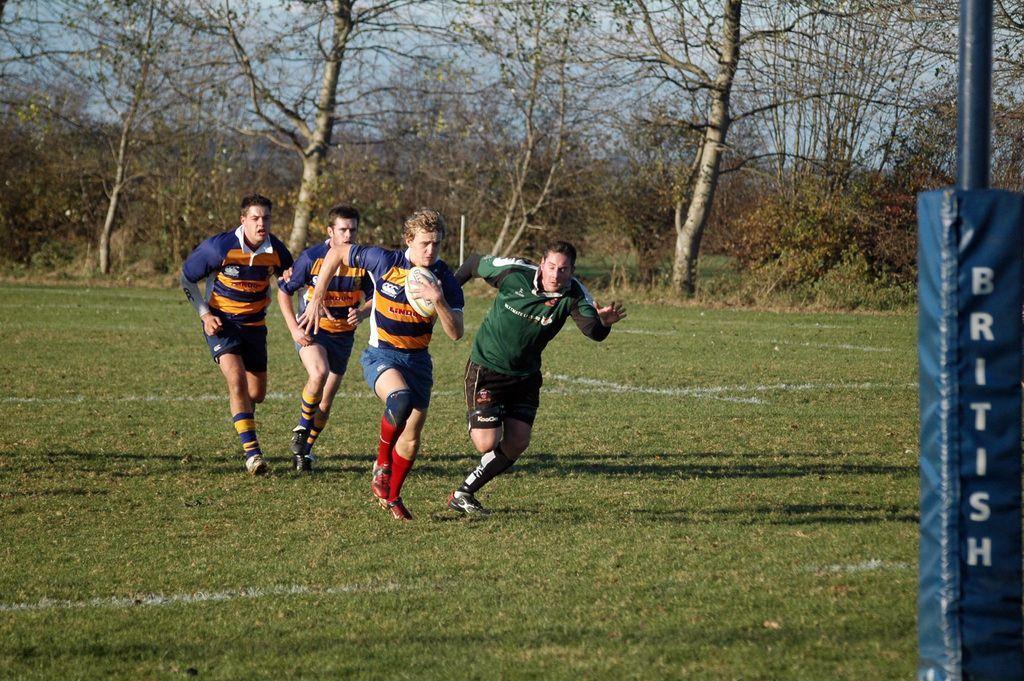Please provide a concise description of this image. In this picture we can see four players, playing the rugby game on the ground. Behind there are some dry trees. 